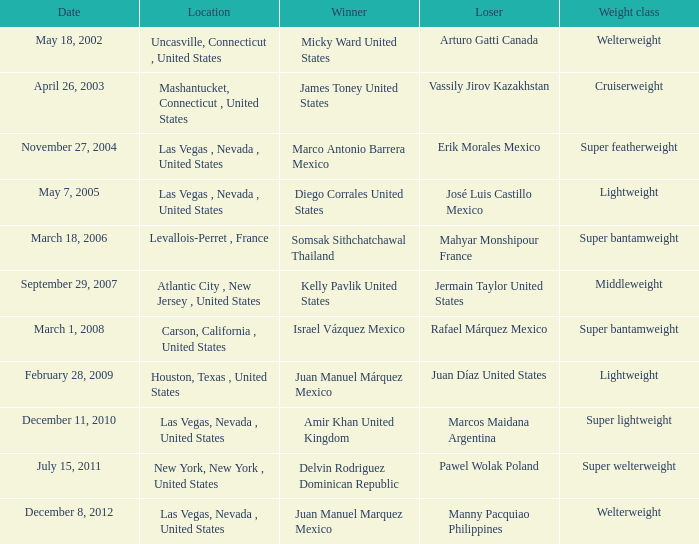On february 28, 2009, how many years had the lightweight class been in existence? 1.0. 